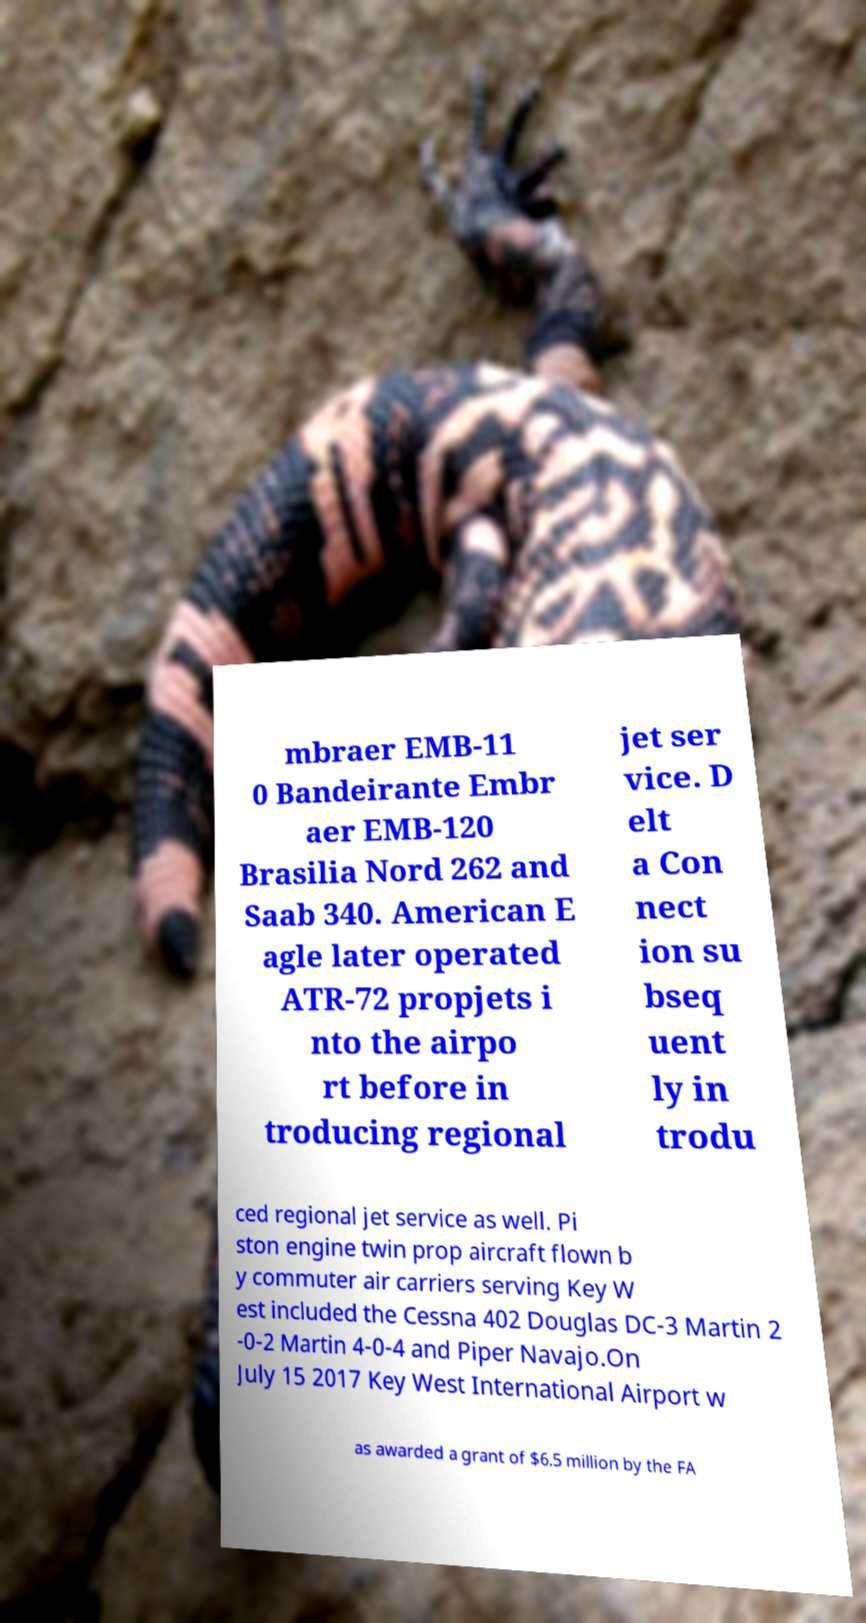What messages or text are displayed in this image? I need them in a readable, typed format. mbraer EMB-11 0 Bandeirante Embr aer EMB-120 Brasilia Nord 262 and Saab 340. American E agle later operated ATR-72 propjets i nto the airpo rt before in troducing regional jet ser vice. D elt a Con nect ion su bseq uent ly in trodu ced regional jet service as well. Pi ston engine twin prop aircraft flown b y commuter air carriers serving Key W est included the Cessna 402 Douglas DC-3 Martin 2 -0-2 Martin 4-0-4 and Piper Navajo.On July 15 2017 Key West International Airport w as awarded a grant of $6.5 million by the FA 